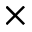Convert formula to latex. <formula><loc_0><loc_0><loc_500><loc_500>\times</formula> 